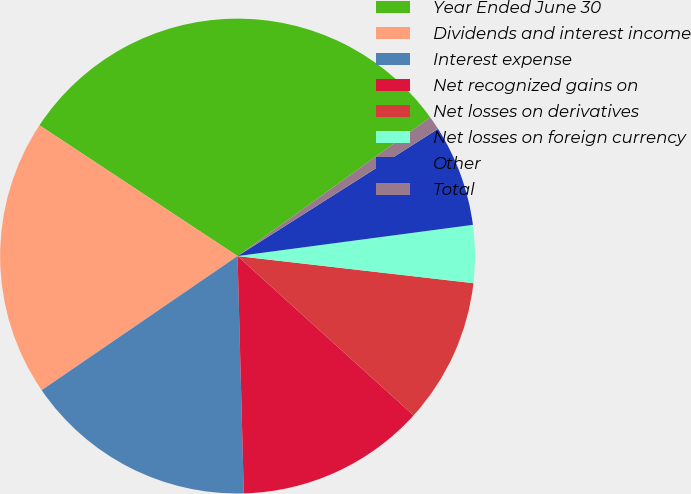Convert chart. <chart><loc_0><loc_0><loc_500><loc_500><pie_chart><fcel>Year Ended June 30<fcel>Dividends and interest income<fcel>Interest expense<fcel>Net recognized gains on<fcel>Net losses on derivatives<fcel>Net losses on foreign currency<fcel>Other<fcel>Total<nl><fcel>30.78%<fcel>18.84%<fcel>15.86%<fcel>12.87%<fcel>9.89%<fcel>3.92%<fcel>6.9%<fcel>0.93%<nl></chart> 